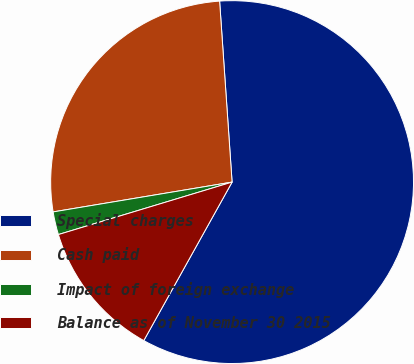<chart> <loc_0><loc_0><loc_500><loc_500><pie_chart><fcel>Special charges<fcel>Cash paid<fcel>Impact of foreign exchange<fcel>Balance as of November 30 2015<nl><fcel>59.18%<fcel>26.53%<fcel>2.04%<fcel>12.24%<nl></chart> 